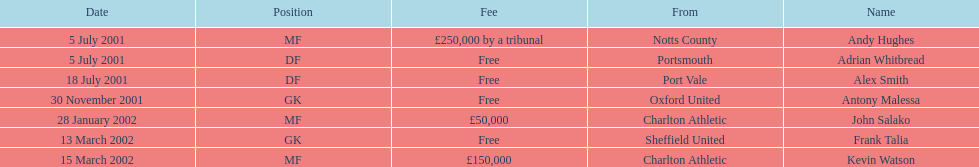Are there a minimum of 2 nationalities displayed on the chart? Yes. 